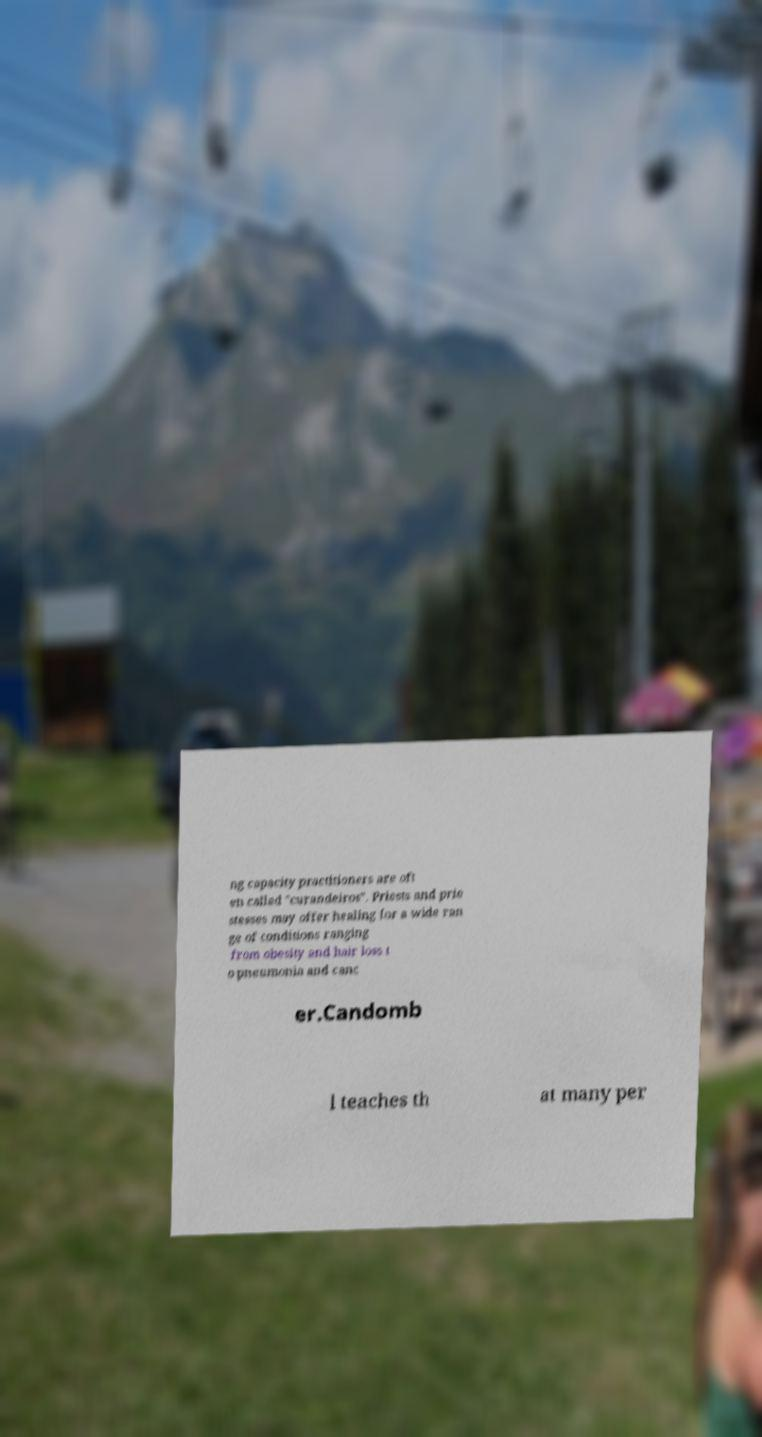Can you accurately transcribe the text from the provided image for me? ng capacity practitioners are oft en called "curandeiros". Priests and prie stesses may offer healing for a wide ran ge of conditions ranging from obesity and hair loss t o pneumonia and canc er.Candomb l teaches th at many per 